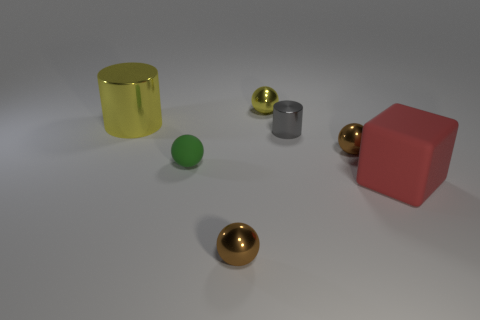How many things are either brown balls that are to the right of the tiny gray object or brown objects that are behind the small rubber thing?
Your response must be concise. 1. What size is the matte thing that is left of the shiny sphere on the left side of the small sphere that is behind the large cylinder?
Offer a very short reply. Small. Is the number of small objects behind the large matte thing the same as the number of tiny balls?
Keep it short and to the point. Yes. Is there any other thing that has the same shape as the red matte object?
Provide a short and direct response. No. Do the tiny green object and the yellow metal object that is right of the big yellow metal thing have the same shape?
Provide a short and direct response. Yes. What is the size of the yellow metallic thing that is the same shape as the small green thing?
Offer a very short reply. Small. How many other objects are there of the same material as the large yellow thing?
Offer a very short reply. 4. What is the material of the yellow sphere?
Ensure brevity in your answer.  Metal. There is a shiny thing to the left of the green matte object; is its color the same as the matte thing that is behind the big red cube?
Ensure brevity in your answer.  No. Is the number of metallic cylinders that are to the right of the green matte sphere greater than the number of tiny red matte objects?
Provide a short and direct response. Yes. 